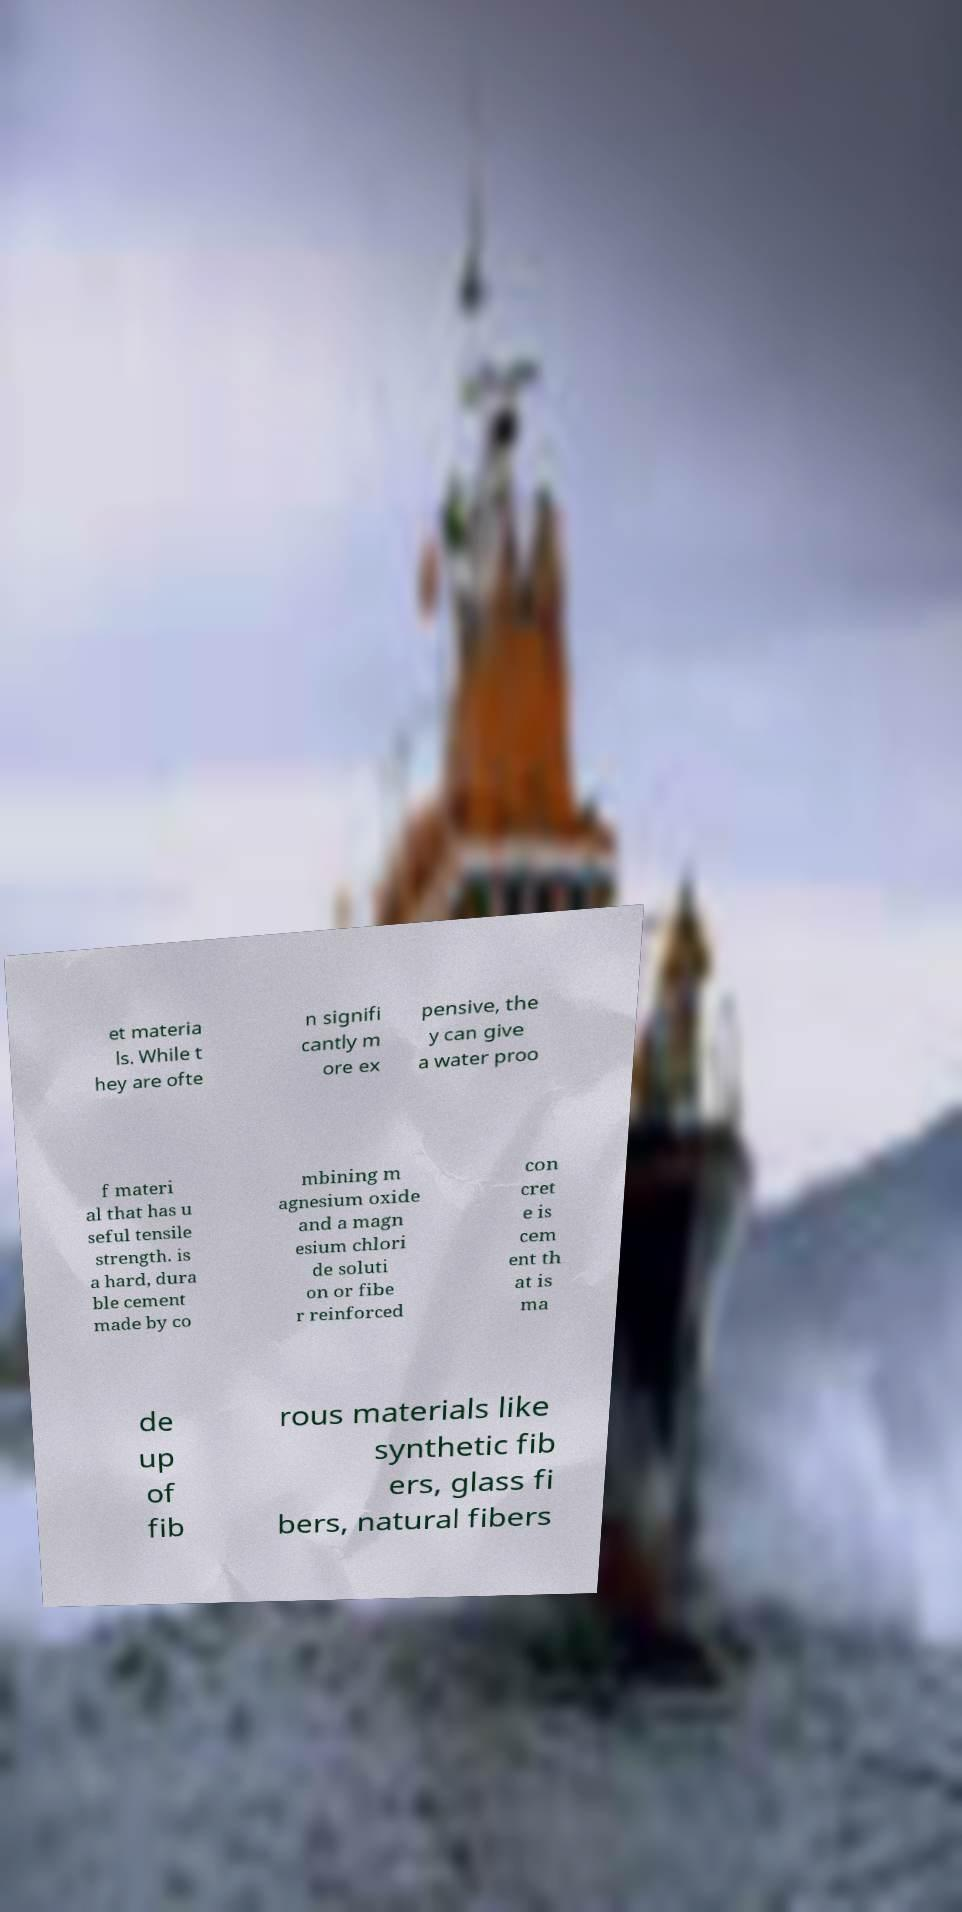For documentation purposes, I need the text within this image transcribed. Could you provide that? et materia ls. While t hey are ofte n signifi cantly m ore ex pensive, the y can give a water proo f materi al that has u seful tensile strength. is a hard, dura ble cement made by co mbining m agnesium oxide and a magn esium chlori de soluti on or fibe r reinforced con cret e is cem ent th at is ma de up of fib rous materials like synthetic fib ers, glass fi bers, natural fibers 